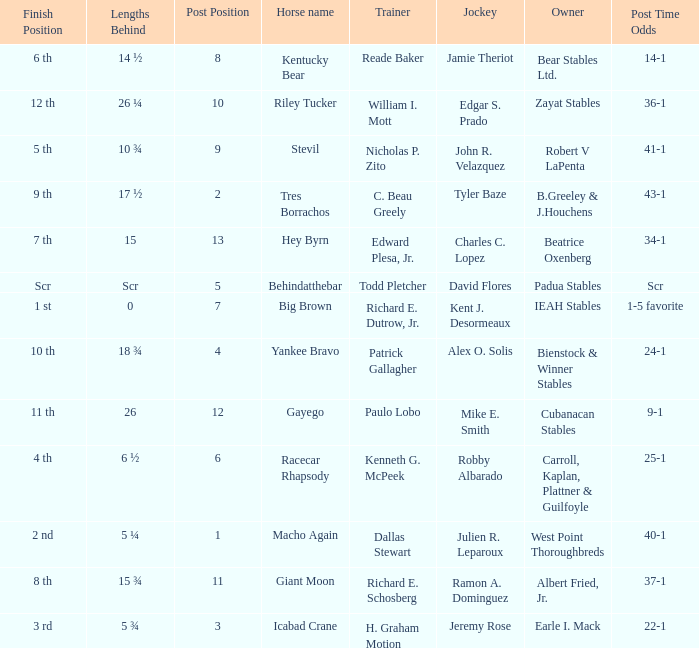Who is the owner of Icabad Crane? Earle I. Mack. 